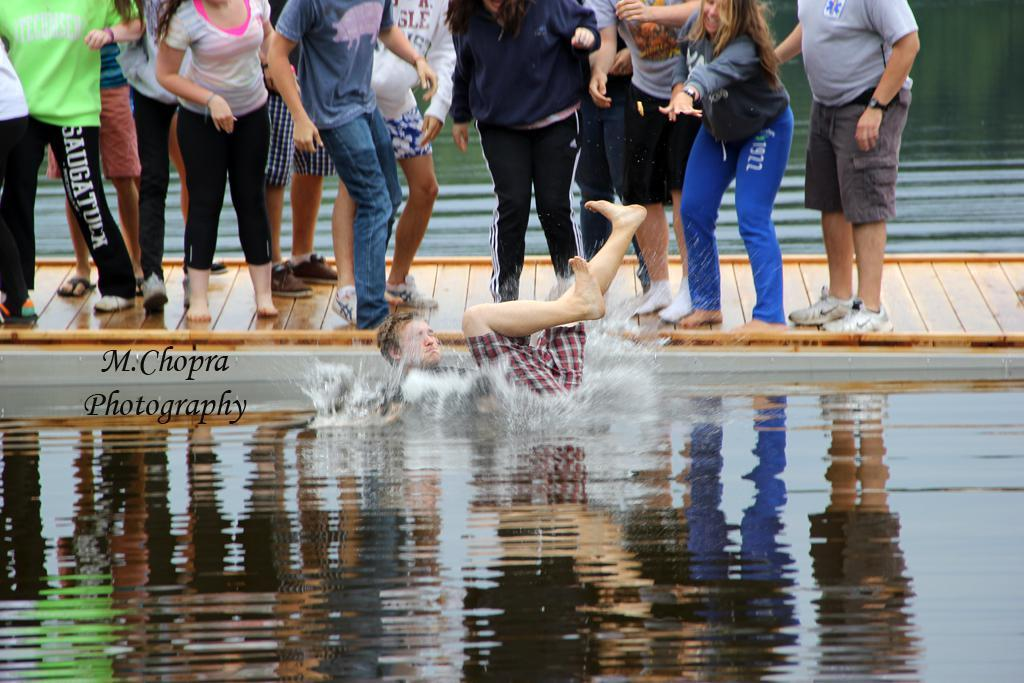What is the man in the image doing on the water? The man is lying down on the water in the image. What can be seen in the background of the image? There are people standing on a footpath in the image. What type of yak can be seen grazing on the coast in the image? There is no yak or coast present in the image; it features a man lying down on the water and people standing on a footpath. 